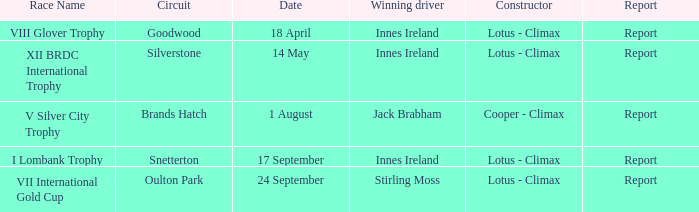What is the appellation of the event in which stirling moss secured victory as the leading racer? VII International Gold Cup. 